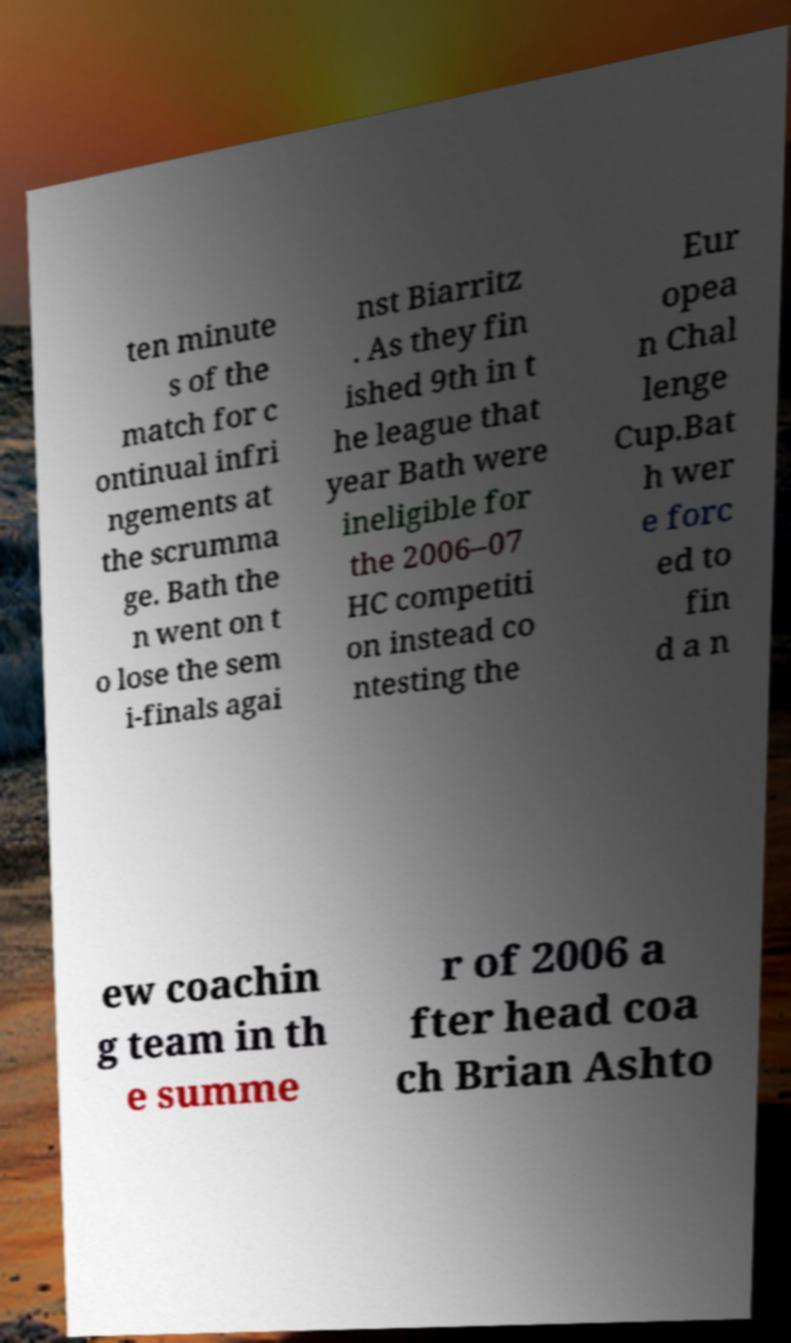Can you accurately transcribe the text from the provided image for me? ten minute s of the match for c ontinual infri ngements at the scrumma ge. Bath the n went on t o lose the sem i-finals agai nst Biarritz . As they fin ished 9th in t he league that year Bath were ineligible for the 2006–07 HC competiti on instead co ntesting the Eur opea n Chal lenge Cup.Bat h wer e forc ed to fin d a n ew coachin g team in th e summe r of 2006 a fter head coa ch Brian Ashto 